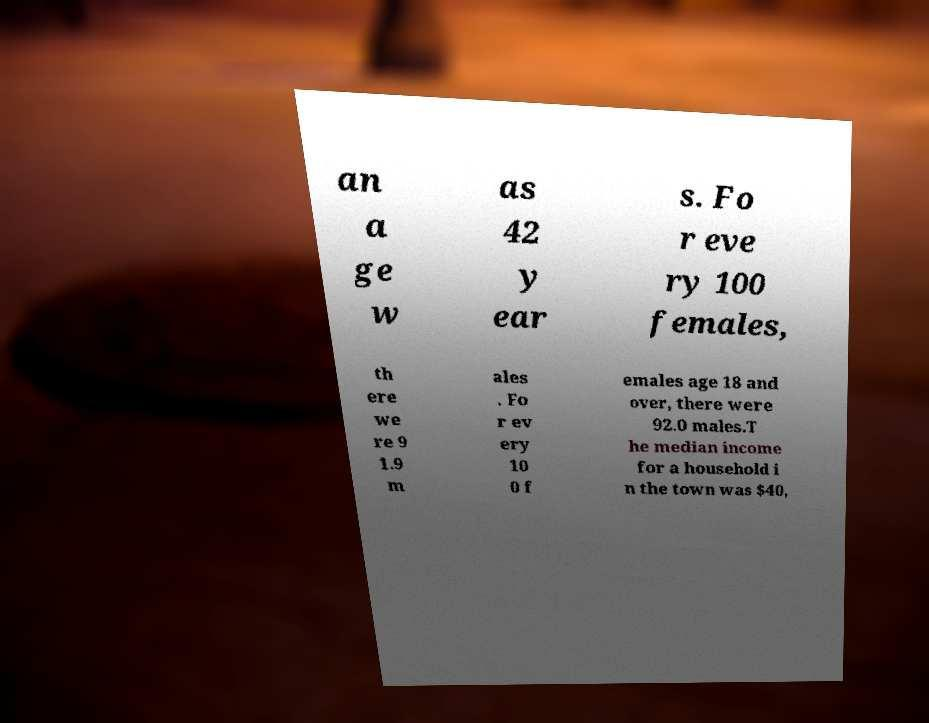What messages or text are displayed in this image? I need them in a readable, typed format. an a ge w as 42 y ear s. Fo r eve ry 100 females, th ere we re 9 1.9 m ales . Fo r ev ery 10 0 f emales age 18 and over, there were 92.0 males.T he median income for a household i n the town was $40, 